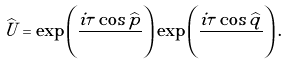<formula> <loc_0><loc_0><loc_500><loc_500>\widehat { U } = \exp \left ( \frac { i \tau \cos \widehat { p } } { } \right ) \exp \left ( \frac { i \tau \cos \widehat { q } } { } \right ) .</formula> 